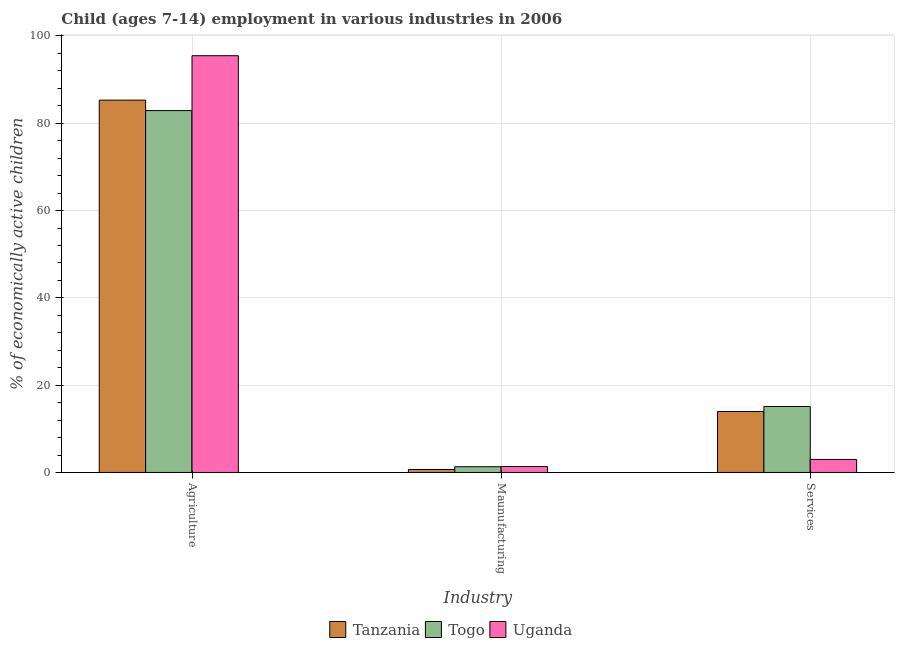How many different coloured bars are there?
Provide a succinct answer. 3. How many groups of bars are there?
Keep it short and to the point. 3. Are the number of bars per tick equal to the number of legend labels?
Keep it short and to the point. Yes. Are the number of bars on each tick of the X-axis equal?
Keep it short and to the point. Yes. What is the label of the 3rd group of bars from the left?
Keep it short and to the point. Services. What is the percentage of economically active children in agriculture in Tanzania?
Make the answer very short. 85.3. Across all countries, what is the maximum percentage of economically active children in services?
Your answer should be very brief. 15.12. Across all countries, what is the minimum percentage of economically active children in manufacturing?
Your response must be concise. 0.69. In which country was the percentage of economically active children in services maximum?
Keep it short and to the point. Togo. In which country was the percentage of economically active children in services minimum?
Your answer should be very brief. Uganda. What is the total percentage of economically active children in agriculture in the graph?
Ensure brevity in your answer.  263.69. What is the difference between the percentage of economically active children in agriculture in Tanzania and that in Togo?
Provide a short and direct response. 2.39. What is the difference between the percentage of economically active children in manufacturing in Uganda and the percentage of economically active children in agriculture in Togo?
Provide a succinct answer. -81.55. What is the average percentage of economically active children in agriculture per country?
Make the answer very short. 87.9. What is the difference between the percentage of economically active children in agriculture and percentage of economically active children in manufacturing in Uganda?
Your answer should be very brief. 94.12. In how many countries, is the percentage of economically active children in services greater than 72 %?
Keep it short and to the point. 0. What is the ratio of the percentage of economically active children in manufacturing in Togo to that in Tanzania?
Your answer should be very brief. 1.91. Is the percentage of economically active children in services in Togo less than that in Uganda?
Provide a succinct answer. No. What is the difference between the highest and the second highest percentage of economically active children in manufacturing?
Make the answer very short. 0.04. What is the difference between the highest and the lowest percentage of economically active children in agriculture?
Provide a short and direct response. 12.57. Is the sum of the percentage of economically active children in manufacturing in Tanzania and Uganda greater than the maximum percentage of economically active children in services across all countries?
Your response must be concise. No. What does the 1st bar from the left in Services represents?
Your answer should be compact. Tanzania. What does the 3rd bar from the right in Agriculture represents?
Offer a terse response. Tanzania. How many bars are there?
Provide a short and direct response. 9. Are all the bars in the graph horizontal?
Offer a terse response. No. What is the difference between two consecutive major ticks on the Y-axis?
Give a very brief answer. 20. Are the values on the major ticks of Y-axis written in scientific E-notation?
Your answer should be compact. No. Does the graph contain any zero values?
Offer a very short reply. No. How many legend labels are there?
Give a very brief answer. 3. What is the title of the graph?
Keep it short and to the point. Child (ages 7-14) employment in various industries in 2006. Does "Romania" appear as one of the legend labels in the graph?
Your response must be concise. No. What is the label or title of the X-axis?
Your answer should be compact. Industry. What is the label or title of the Y-axis?
Make the answer very short. % of economically active children. What is the % of economically active children in Tanzania in Agriculture?
Ensure brevity in your answer.  85.3. What is the % of economically active children in Togo in Agriculture?
Offer a terse response. 82.91. What is the % of economically active children in Uganda in Agriculture?
Ensure brevity in your answer.  95.48. What is the % of economically active children in Tanzania in Maunufacturing?
Provide a short and direct response. 0.69. What is the % of economically active children in Togo in Maunufacturing?
Provide a short and direct response. 1.32. What is the % of economically active children of Uganda in Maunufacturing?
Your response must be concise. 1.36. What is the % of economically active children in Tanzania in Services?
Offer a terse response. 13.97. What is the % of economically active children in Togo in Services?
Offer a terse response. 15.12. What is the % of economically active children of Uganda in Services?
Make the answer very short. 2.99. Across all Industry, what is the maximum % of economically active children in Tanzania?
Your answer should be compact. 85.3. Across all Industry, what is the maximum % of economically active children of Togo?
Offer a very short reply. 82.91. Across all Industry, what is the maximum % of economically active children in Uganda?
Offer a very short reply. 95.48. Across all Industry, what is the minimum % of economically active children of Tanzania?
Ensure brevity in your answer.  0.69. Across all Industry, what is the minimum % of economically active children of Togo?
Your answer should be very brief. 1.32. Across all Industry, what is the minimum % of economically active children in Uganda?
Your answer should be very brief. 1.36. What is the total % of economically active children in Tanzania in the graph?
Make the answer very short. 99.96. What is the total % of economically active children in Togo in the graph?
Offer a very short reply. 99.35. What is the total % of economically active children of Uganda in the graph?
Give a very brief answer. 99.83. What is the difference between the % of economically active children of Tanzania in Agriculture and that in Maunufacturing?
Provide a short and direct response. 84.61. What is the difference between the % of economically active children of Togo in Agriculture and that in Maunufacturing?
Provide a short and direct response. 81.59. What is the difference between the % of economically active children in Uganda in Agriculture and that in Maunufacturing?
Provide a succinct answer. 94.12. What is the difference between the % of economically active children in Tanzania in Agriculture and that in Services?
Your answer should be very brief. 71.33. What is the difference between the % of economically active children of Togo in Agriculture and that in Services?
Provide a succinct answer. 67.79. What is the difference between the % of economically active children of Uganda in Agriculture and that in Services?
Provide a succinct answer. 92.49. What is the difference between the % of economically active children in Tanzania in Maunufacturing and that in Services?
Provide a succinct answer. -13.28. What is the difference between the % of economically active children in Togo in Maunufacturing and that in Services?
Make the answer very short. -13.8. What is the difference between the % of economically active children in Uganda in Maunufacturing and that in Services?
Offer a very short reply. -1.63. What is the difference between the % of economically active children of Tanzania in Agriculture and the % of economically active children of Togo in Maunufacturing?
Make the answer very short. 83.98. What is the difference between the % of economically active children in Tanzania in Agriculture and the % of economically active children in Uganda in Maunufacturing?
Offer a very short reply. 83.94. What is the difference between the % of economically active children of Togo in Agriculture and the % of economically active children of Uganda in Maunufacturing?
Offer a very short reply. 81.55. What is the difference between the % of economically active children of Tanzania in Agriculture and the % of economically active children of Togo in Services?
Provide a succinct answer. 70.18. What is the difference between the % of economically active children in Tanzania in Agriculture and the % of economically active children in Uganda in Services?
Offer a terse response. 82.31. What is the difference between the % of economically active children of Togo in Agriculture and the % of economically active children of Uganda in Services?
Provide a succinct answer. 79.92. What is the difference between the % of economically active children in Tanzania in Maunufacturing and the % of economically active children in Togo in Services?
Provide a succinct answer. -14.43. What is the difference between the % of economically active children of Tanzania in Maunufacturing and the % of economically active children of Uganda in Services?
Offer a terse response. -2.3. What is the difference between the % of economically active children in Togo in Maunufacturing and the % of economically active children in Uganda in Services?
Give a very brief answer. -1.67. What is the average % of economically active children in Tanzania per Industry?
Ensure brevity in your answer.  33.32. What is the average % of economically active children of Togo per Industry?
Make the answer very short. 33.12. What is the average % of economically active children in Uganda per Industry?
Offer a terse response. 33.28. What is the difference between the % of economically active children of Tanzania and % of economically active children of Togo in Agriculture?
Offer a very short reply. 2.39. What is the difference between the % of economically active children in Tanzania and % of economically active children in Uganda in Agriculture?
Offer a very short reply. -10.18. What is the difference between the % of economically active children in Togo and % of economically active children in Uganda in Agriculture?
Give a very brief answer. -12.57. What is the difference between the % of economically active children in Tanzania and % of economically active children in Togo in Maunufacturing?
Provide a succinct answer. -0.63. What is the difference between the % of economically active children of Tanzania and % of economically active children of Uganda in Maunufacturing?
Your answer should be compact. -0.67. What is the difference between the % of economically active children in Togo and % of economically active children in Uganda in Maunufacturing?
Your response must be concise. -0.04. What is the difference between the % of economically active children in Tanzania and % of economically active children in Togo in Services?
Your response must be concise. -1.15. What is the difference between the % of economically active children of Tanzania and % of economically active children of Uganda in Services?
Provide a succinct answer. 10.98. What is the difference between the % of economically active children of Togo and % of economically active children of Uganda in Services?
Keep it short and to the point. 12.13. What is the ratio of the % of economically active children in Tanzania in Agriculture to that in Maunufacturing?
Offer a terse response. 123.62. What is the ratio of the % of economically active children in Togo in Agriculture to that in Maunufacturing?
Ensure brevity in your answer.  62.81. What is the ratio of the % of economically active children of Uganda in Agriculture to that in Maunufacturing?
Give a very brief answer. 70.21. What is the ratio of the % of economically active children in Tanzania in Agriculture to that in Services?
Your response must be concise. 6.11. What is the ratio of the % of economically active children in Togo in Agriculture to that in Services?
Provide a succinct answer. 5.48. What is the ratio of the % of economically active children in Uganda in Agriculture to that in Services?
Ensure brevity in your answer.  31.93. What is the ratio of the % of economically active children in Tanzania in Maunufacturing to that in Services?
Provide a short and direct response. 0.05. What is the ratio of the % of economically active children in Togo in Maunufacturing to that in Services?
Offer a very short reply. 0.09. What is the ratio of the % of economically active children in Uganda in Maunufacturing to that in Services?
Provide a short and direct response. 0.45. What is the difference between the highest and the second highest % of economically active children of Tanzania?
Your answer should be compact. 71.33. What is the difference between the highest and the second highest % of economically active children in Togo?
Keep it short and to the point. 67.79. What is the difference between the highest and the second highest % of economically active children in Uganda?
Provide a short and direct response. 92.49. What is the difference between the highest and the lowest % of economically active children of Tanzania?
Your answer should be compact. 84.61. What is the difference between the highest and the lowest % of economically active children of Togo?
Provide a succinct answer. 81.59. What is the difference between the highest and the lowest % of economically active children in Uganda?
Ensure brevity in your answer.  94.12. 